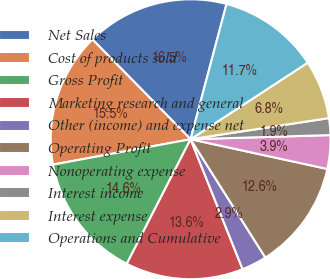<chart> <loc_0><loc_0><loc_500><loc_500><pie_chart><fcel>Net Sales<fcel>Cost of products sold<fcel>Gross Profit<fcel>Marketing research and general<fcel>Other (income) and expense net<fcel>Operating Profit<fcel>Nonoperating expense<fcel>Interest income<fcel>Interest expense<fcel>Operations and Cumulative<nl><fcel>16.5%<fcel>15.53%<fcel>14.56%<fcel>13.59%<fcel>2.91%<fcel>12.62%<fcel>3.88%<fcel>1.94%<fcel>6.8%<fcel>11.65%<nl></chart> 